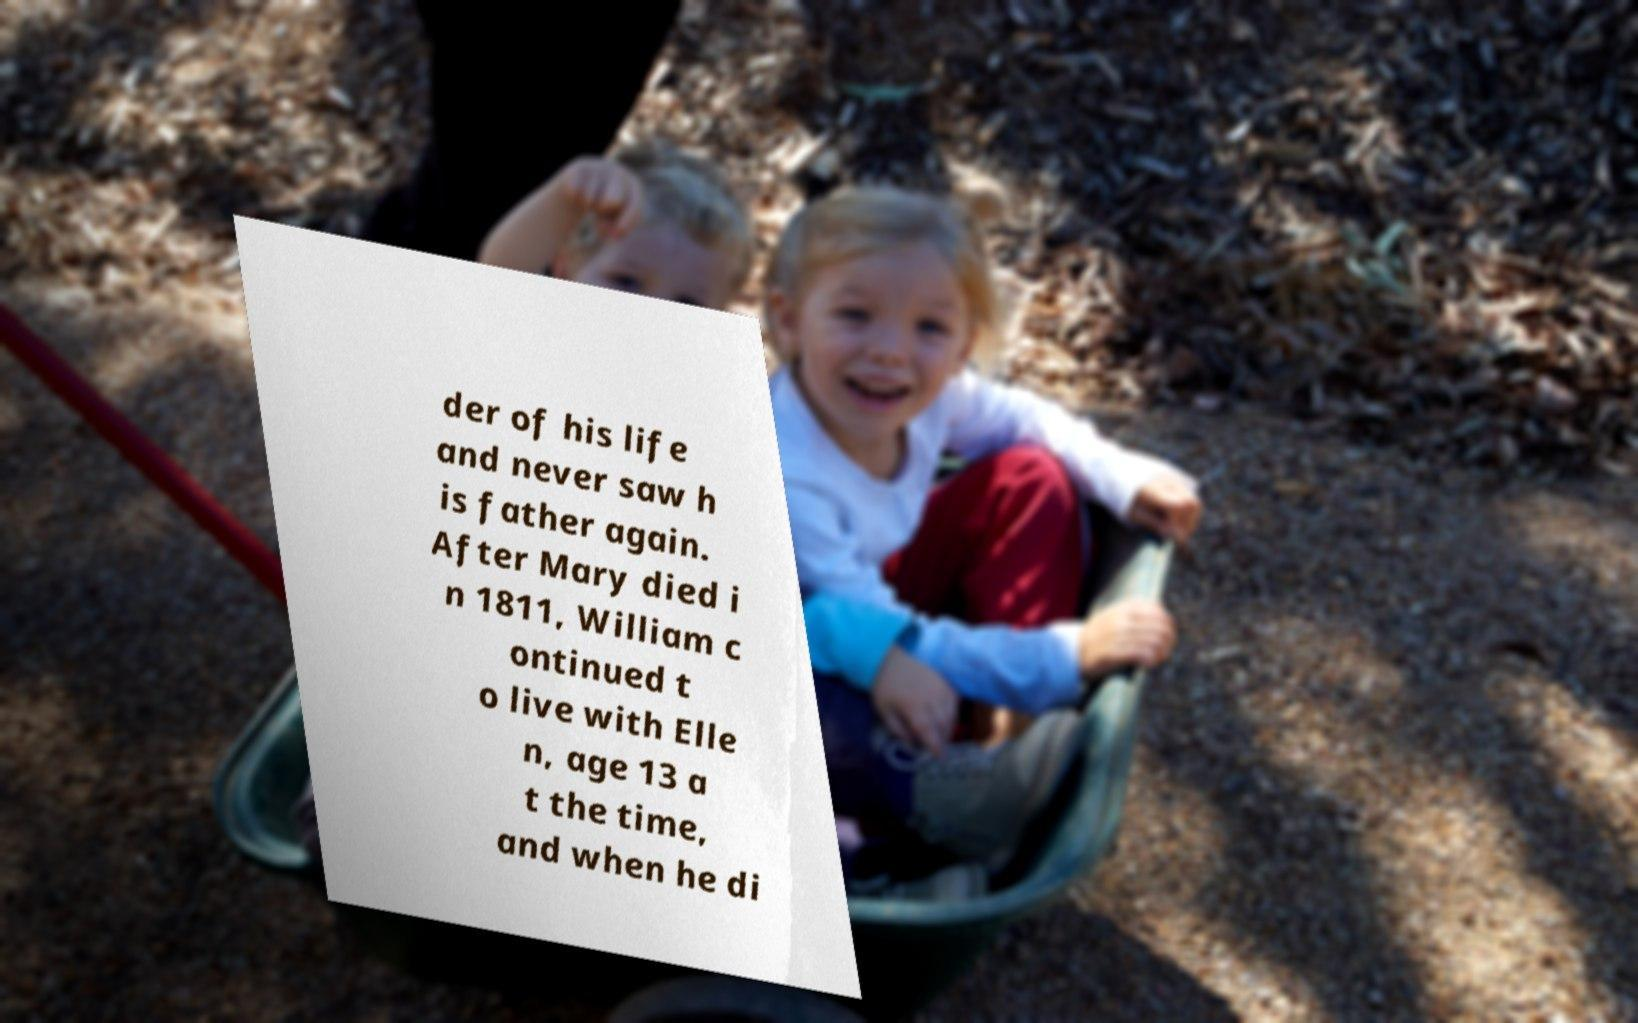Please read and relay the text visible in this image. What does it say? der of his life and never saw h is father again. After Mary died i n 1811, William c ontinued t o live with Elle n, age 13 a t the time, and when he di 